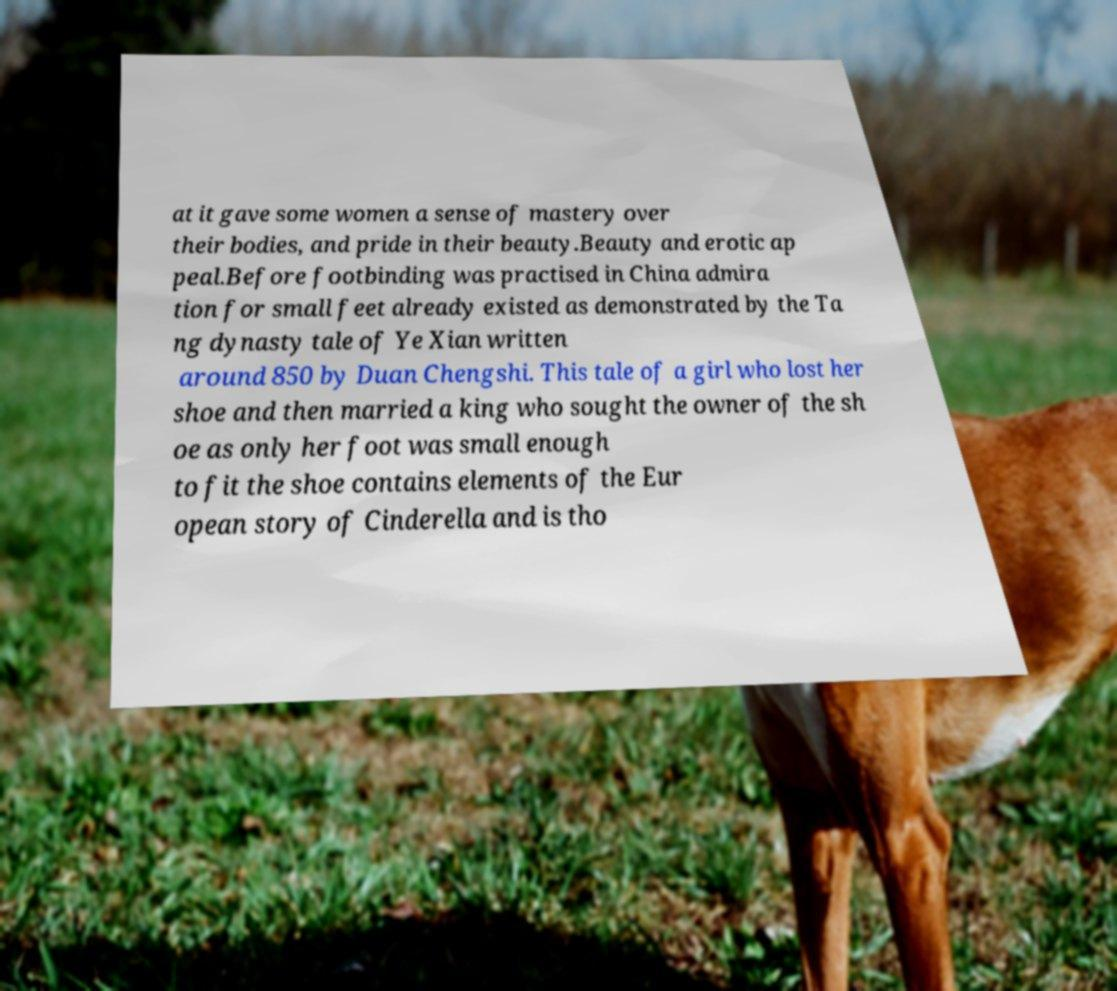Please identify and transcribe the text found in this image. at it gave some women a sense of mastery over their bodies, and pride in their beauty.Beauty and erotic ap peal.Before footbinding was practised in China admira tion for small feet already existed as demonstrated by the Ta ng dynasty tale of Ye Xian written around 850 by Duan Chengshi. This tale of a girl who lost her shoe and then married a king who sought the owner of the sh oe as only her foot was small enough to fit the shoe contains elements of the Eur opean story of Cinderella and is tho 